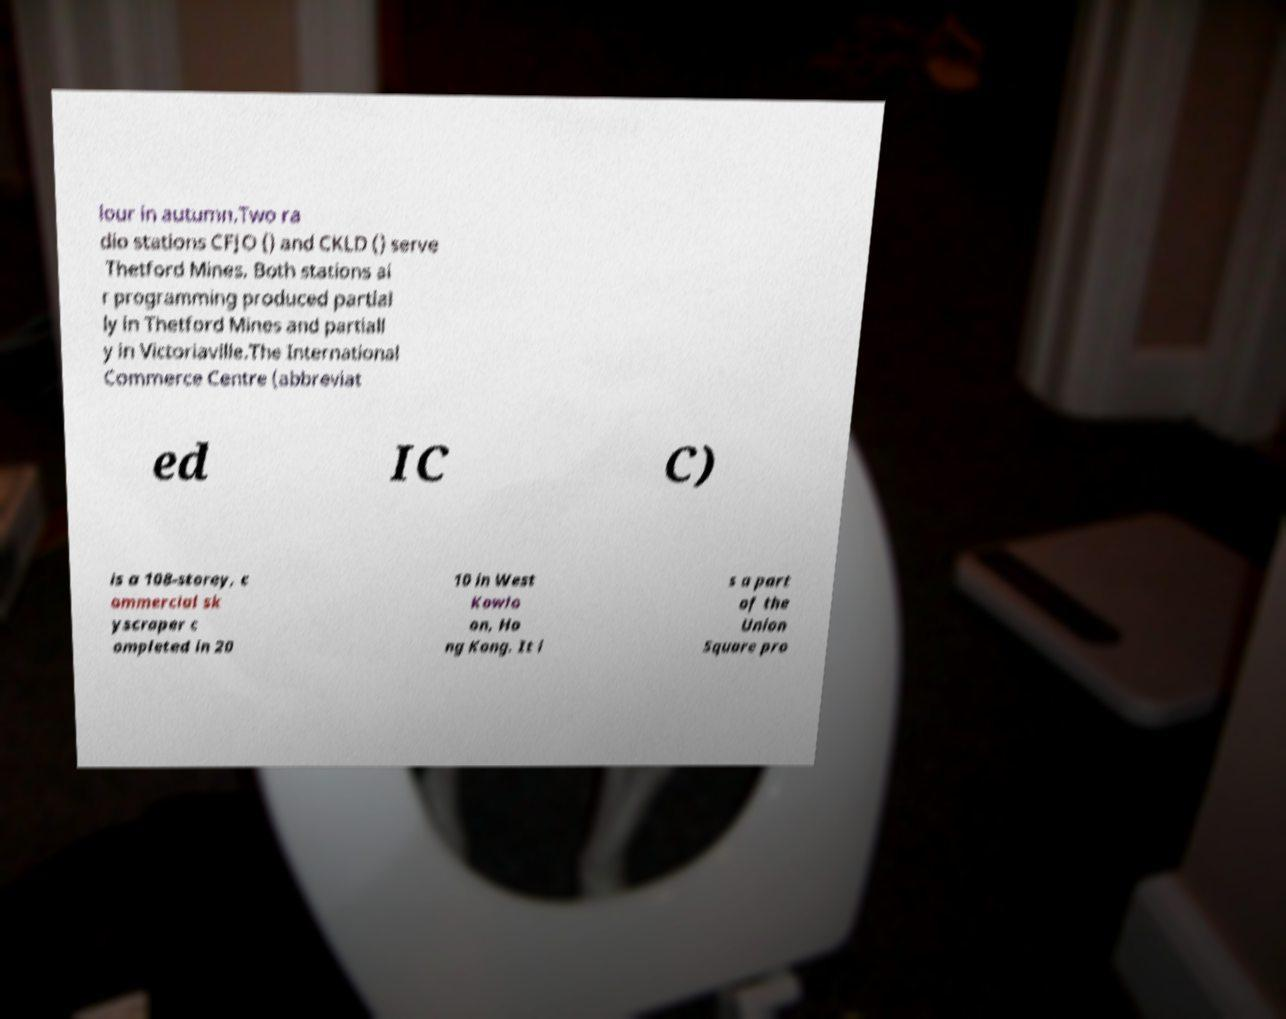I need the written content from this picture converted into text. Can you do that? lour in autumn.Two ra dio stations CFJO () and CKLD () serve Thetford Mines. Both stations ai r programming produced partial ly in Thetford Mines and partiall y in Victoriaville.The International Commerce Centre (abbreviat ed IC C) is a 108-storey, c ommercial sk yscraper c ompleted in 20 10 in West Kowlo on, Ho ng Kong. It i s a part of the Union Square pro 